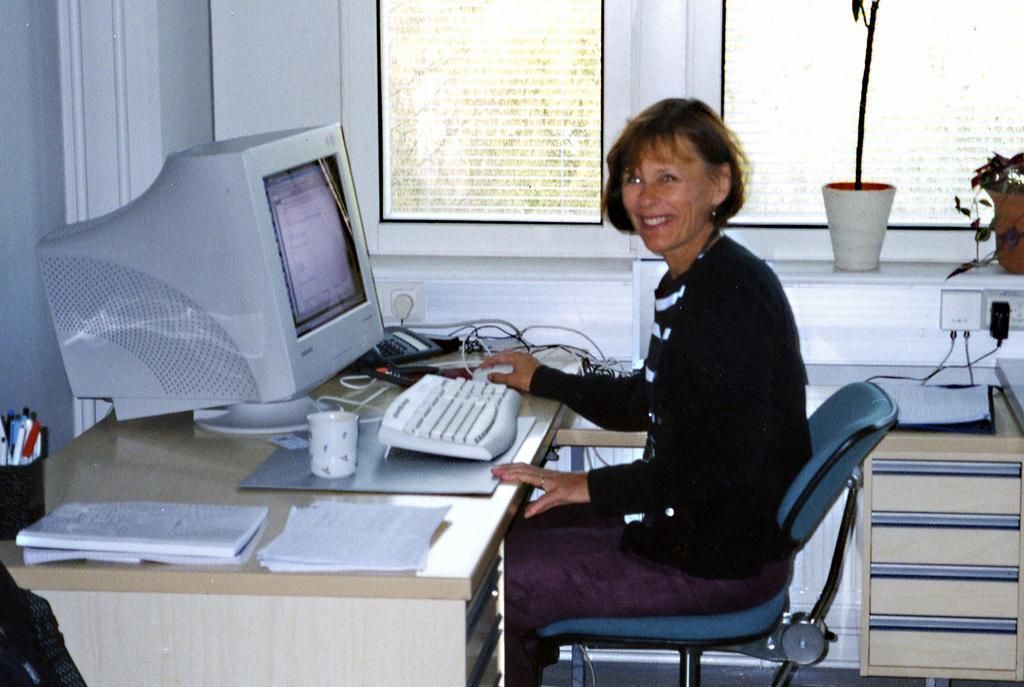Can you describe this image briefly? On the background we can see windows. Through window glass we can see trees. This is a houseplant. This is a socket. Here we can see one woman sitting on a chair and she is smiling. On the table we can see penguins in a mug, cup, book, papers, keyboard, mouse and computer. This is a desk. 